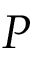Convert formula to latex. <formula><loc_0><loc_0><loc_500><loc_500>P</formula> 